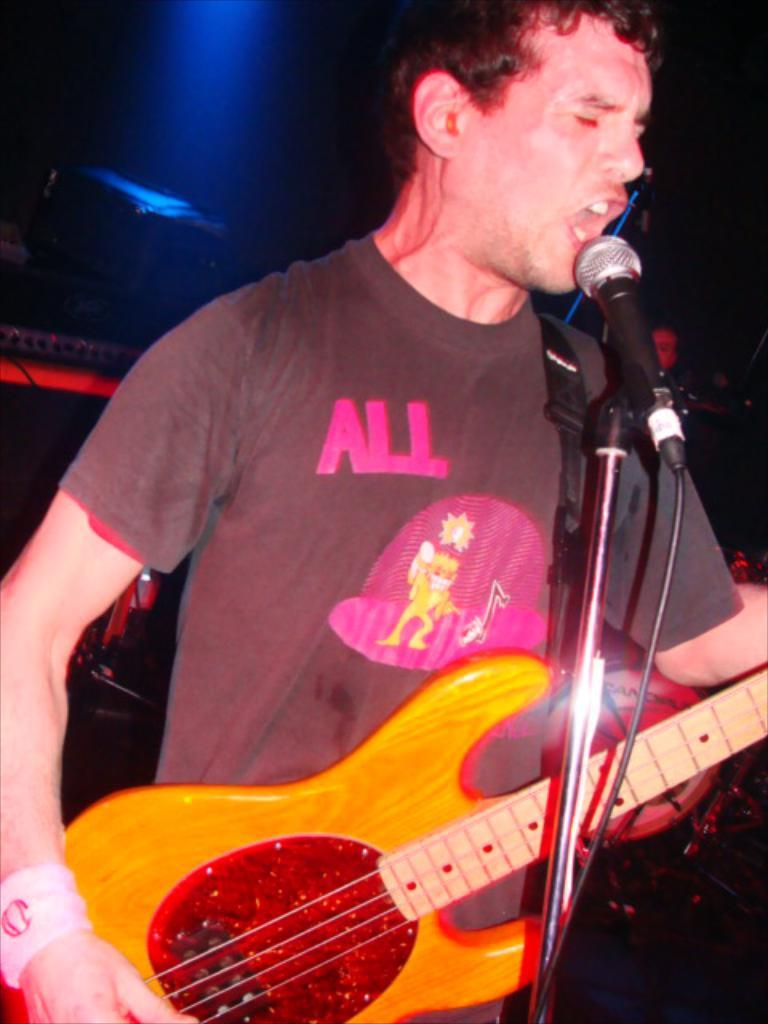Who is the main subject in the image? There is a person in the image. Where is the person located in the image? The person is at the center of the image. What is the person doing in the image? The person is singing. What instrument is the person holding in the image? The person is holding a guitar. What device is being used for amplifying the person's voice? There is a microphone involved. What type of lighting is being used to highlight the person in the image? There is a spotlight behind the person. What type of joke is the person telling in the image? There is no joke being told in the image; the person is singing. What type of knowledge is being shared by the person in the image? There is no indication of knowledge being shared in the image; the person is singing and playing a guitar. 